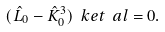Convert formula to latex. <formula><loc_0><loc_0><loc_500><loc_500>( \hat { L } _ { 0 } - \hat { K } ^ { 3 } _ { 0 } ) \ k e t { \ a l } = 0 .</formula> 